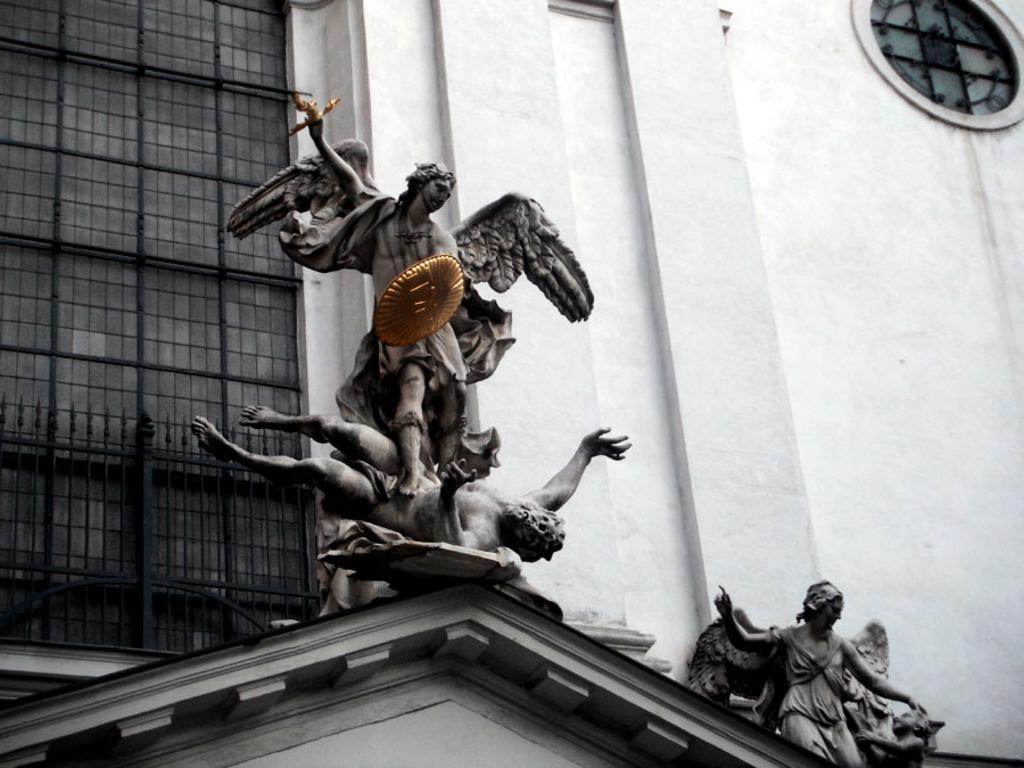What type of objects are in the middle of the image? There are statues of humans in the image. What can be seen behind the statues? There is a building behind the statues. What type of laborer can be seen working on the patch in the image? There is no laborer or patch present in the image; it features statues of humans and a building. 